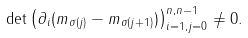<formula> <loc_0><loc_0><loc_500><loc_500>\det \left ( \partial _ { i } ( m _ { \sigma ( j ) } - m _ { \sigma ( j + 1 ) } ) \right ) _ { i = 1 , j = 0 } ^ { n , n - 1 } \neq 0 .</formula> 